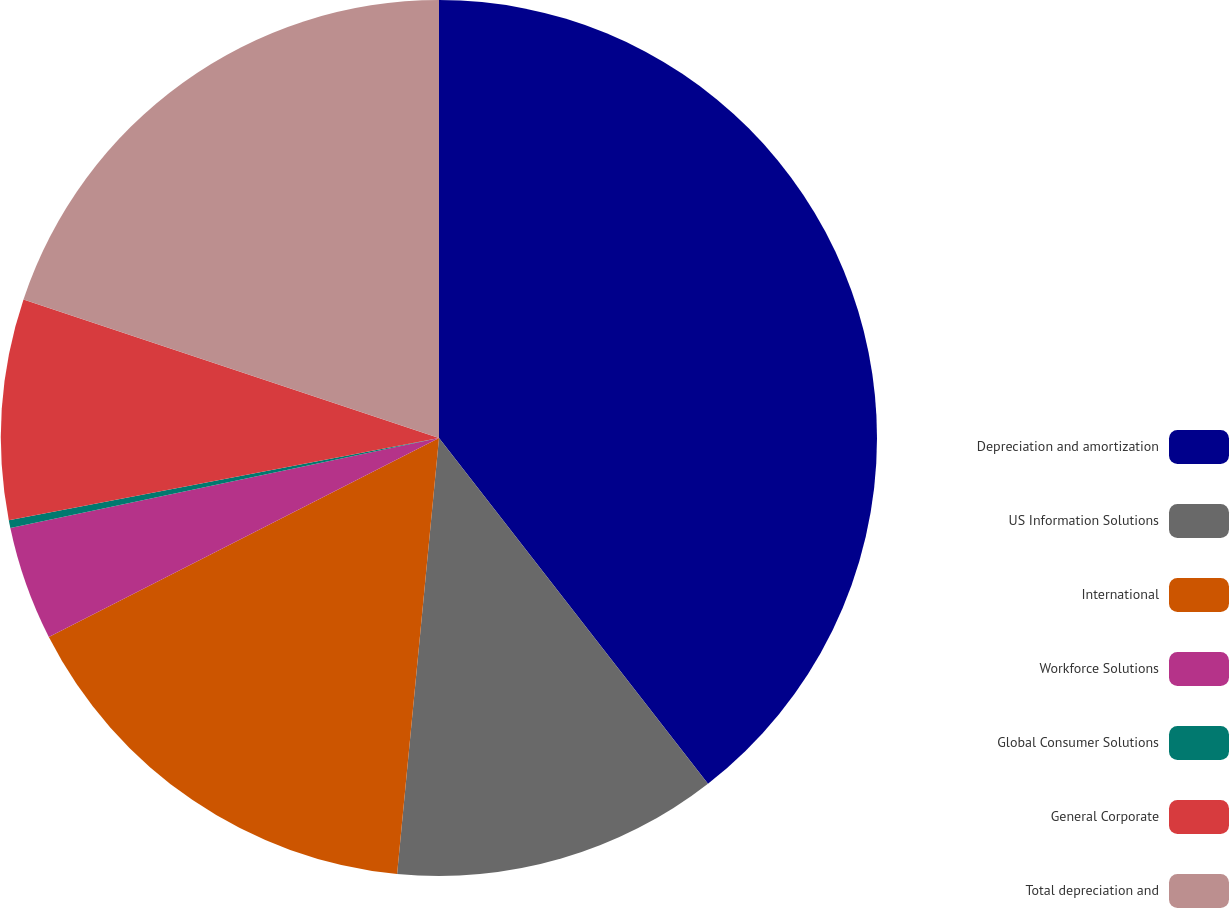<chart> <loc_0><loc_0><loc_500><loc_500><pie_chart><fcel>Depreciation and amortization<fcel>US Information Solutions<fcel>International<fcel>Workforce Solutions<fcel>Global Consumer Solutions<fcel>General Corporate<fcel>Total depreciation and<nl><fcel>39.48%<fcel>12.05%<fcel>15.97%<fcel>4.21%<fcel>0.29%<fcel>8.13%<fcel>19.88%<nl></chart> 